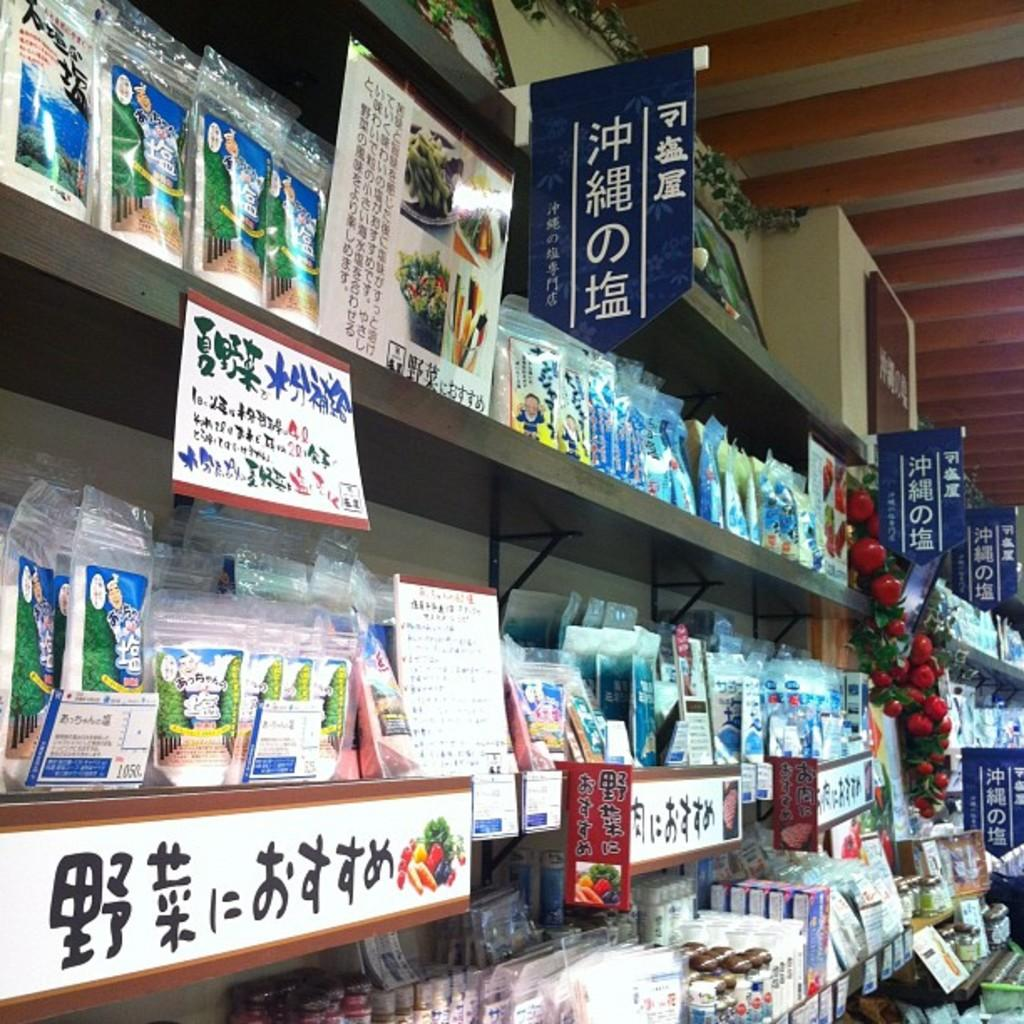<image>
Render a clear and concise summary of the photo. Several shelves of products with text written in Japanese. 